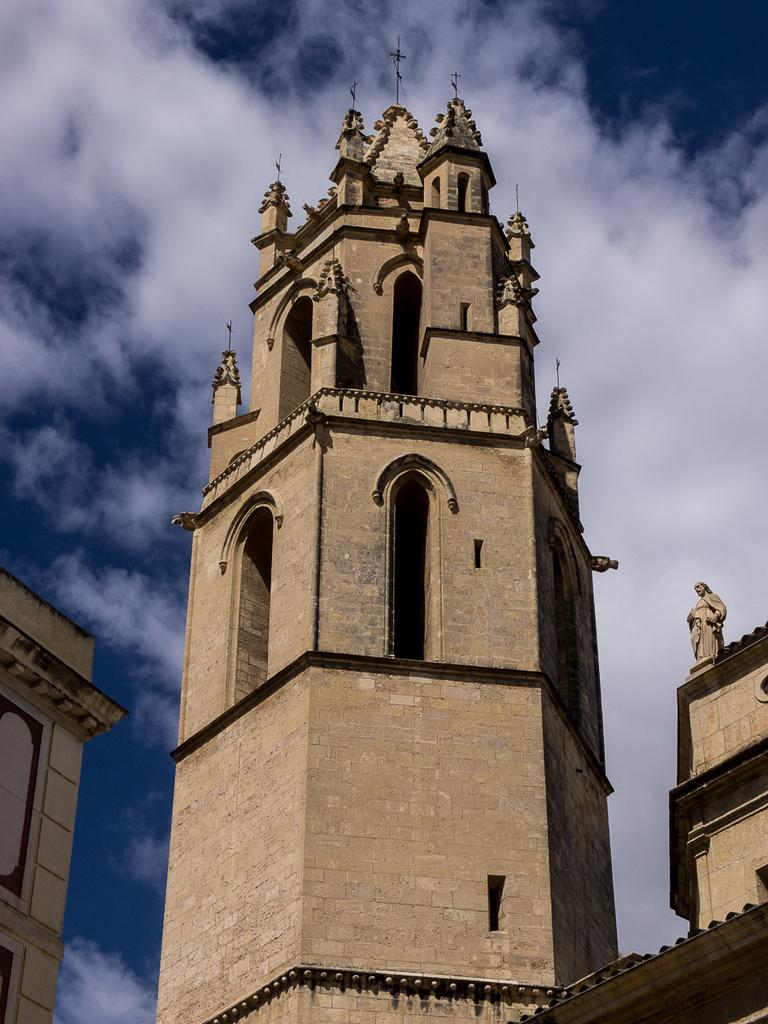What is the main subject in the center of the image? There is a building in the center of the image. What can be seen on both sides of the central building? There are buildings on both the right and left sides of the image. What is visible at the top of the image? The sky is visible at the top of the image. What is located on the right side of the image, besides the buildings? There is a statue on the right side of the image. What type of clam is sitting on top of the statue in the image? There is no clam present in the image; the statue is the only object mentioned on the right side. 